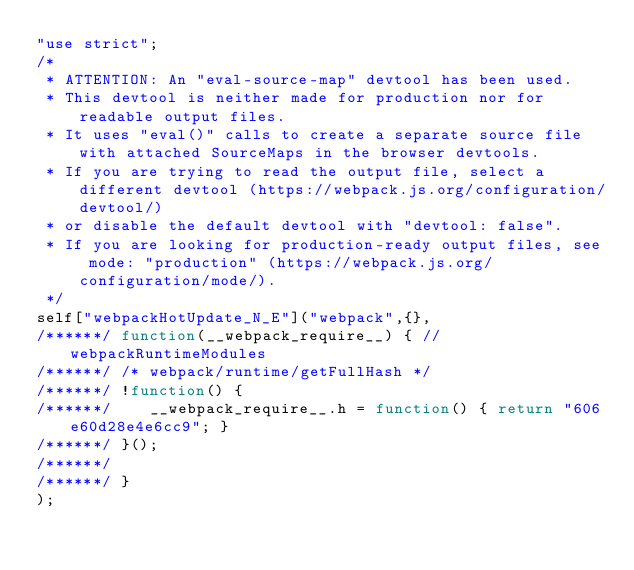Convert code to text. <code><loc_0><loc_0><loc_500><loc_500><_JavaScript_>"use strict";
/*
 * ATTENTION: An "eval-source-map" devtool has been used.
 * This devtool is neither made for production nor for readable output files.
 * It uses "eval()" calls to create a separate source file with attached SourceMaps in the browser devtools.
 * If you are trying to read the output file, select a different devtool (https://webpack.js.org/configuration/devtool/)
 * or disable the default devtool with "devtool: false".
 * If you are looking for production-ready output files, see mode: "production" (https://webpack.js.org/configuration/mode/).
 */
self["webpackHotUpdate_N_E"]("webpack",{},
/******/ function(__webpack_require__) { // webpackRuntimeModules
/******/ /* webpack/runtime/getFullHash */
/******/ !function() {
/******/ 	__webpack_require__.h = function() { return "606e60d28e4e6cc9"; }
/******/ }();
/******/ 
/******/ }
);</code> 